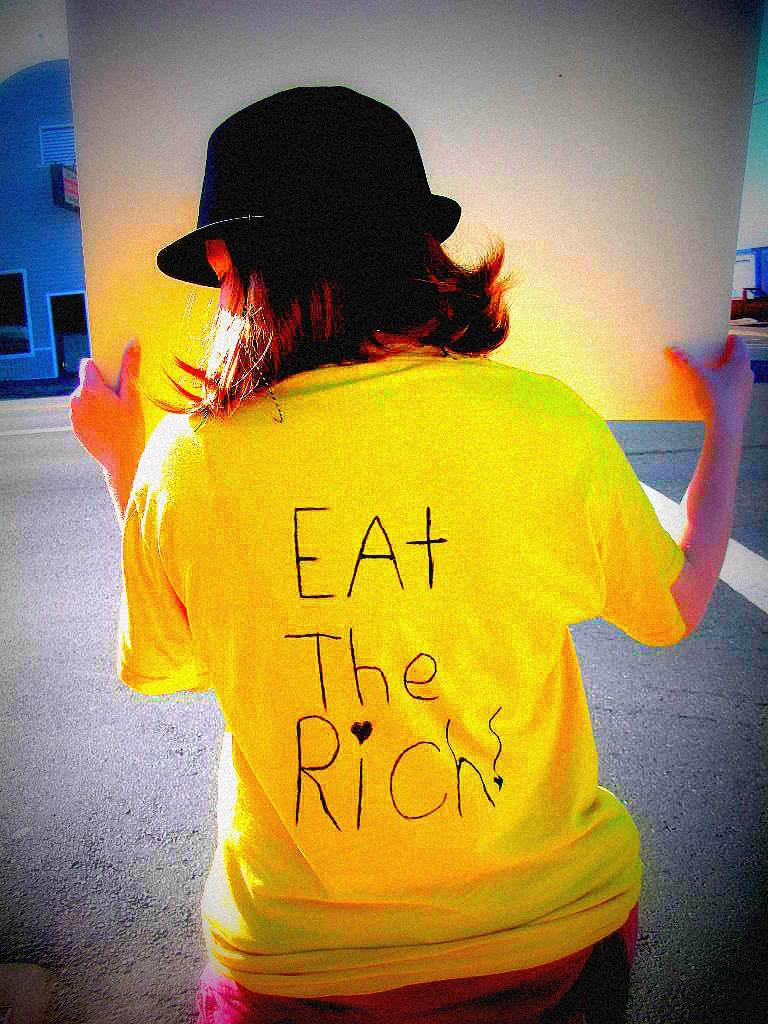What is the person in the image holding? The person is holding a board in the image. Can you describe the person's clothing? The person is wearing a black cap and a yellow dress. What is the color of the building in the image? The building in the image is blue. What else can be seen around the person and the building? There are objects visible around the person and the building. What flavor of ink is being used by the person in the image? There is no ink or writing instrument visible in the image, so it is not possible to determine the flavor of ink being used. 